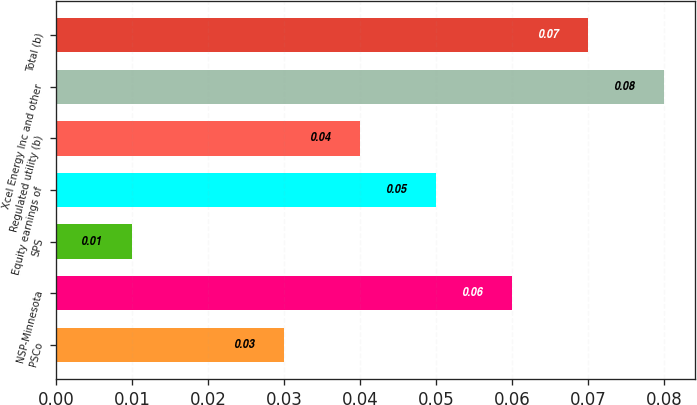<chart> <loc_0><loc_0><loc_500><loc_500><bar_chart><fcel>PSCo<fcel>NSP-Minnesota<fcel>SPS<fcel>Equity earnings of<fcel>Regulated utility (b)<fcel>Xcel Energy Inc and other<fcel>Total (b)<nl><fcel>0.03<fcel>0.06<fcel>0.01<fcel>0.05<fcel>0.04<fcel>0.08<fcel>0.07<nl></chart> 